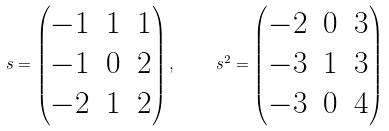<formula> <loc_0><loc_0><loc_500><loc_500>\ s = \begin{pmatrix} - 1 & 1 & 1 \\ - 1 & 0 & 2 \\ - 2 & 1 & 2 \end{pmatrix} , \quad \ s ^ { 2 } = \begin{pmatrix} - 2 & 0 & 3 \\ - 3 & 1 & 3 \\ - 3 & 0 & 4 \end{pmatrix}</formula> 